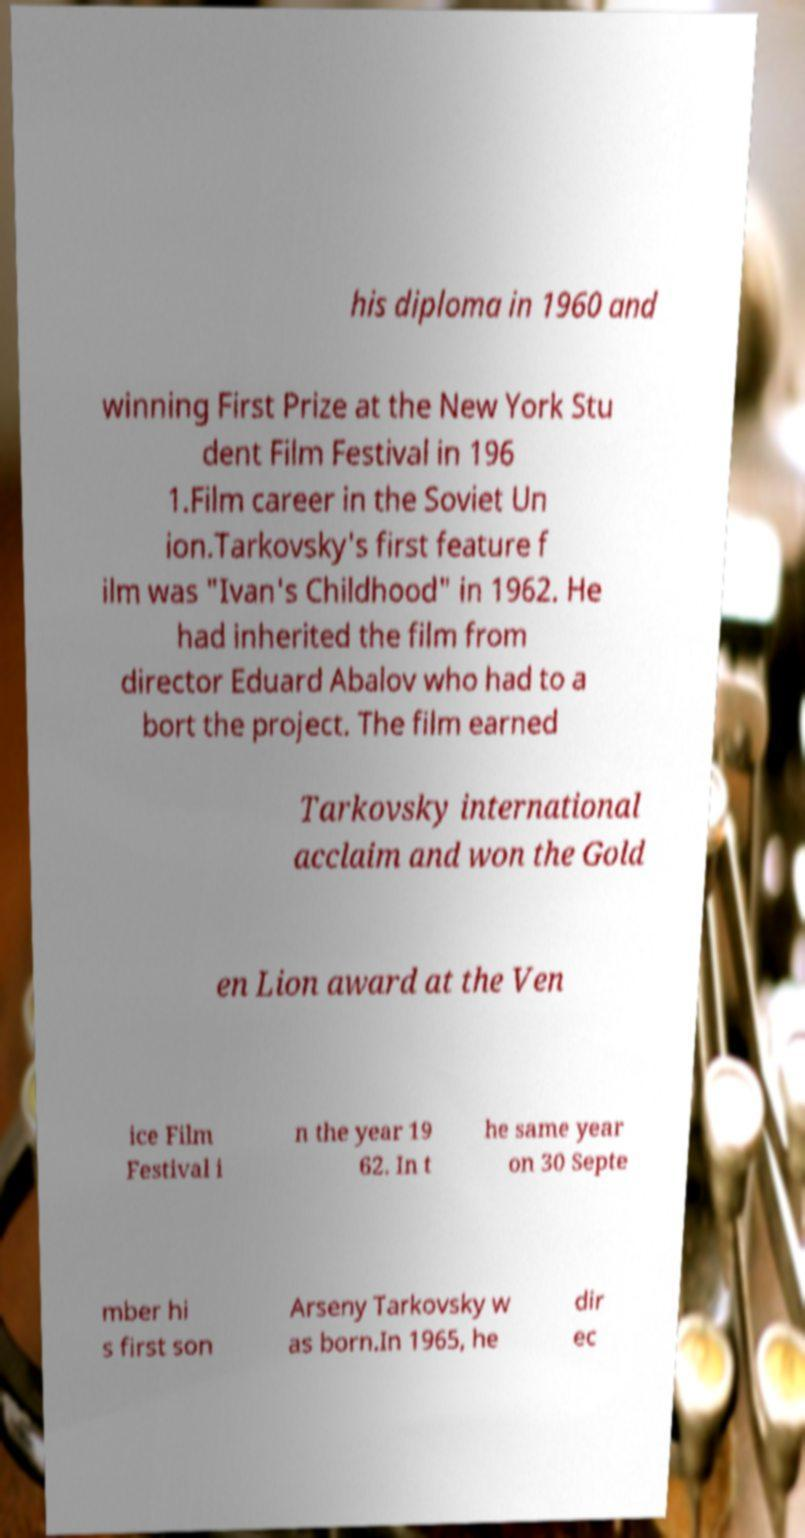There's text embedded in this image that I need extracted. Can you transcribe it verbatim? his diploma in 1960 and winning First Prize at the New York Stu dent Film Festival in 196 1.Film career in the Soviet Un ion.Tarkovsky's first feature f ilm was "Ivan's Childhood" in 1962. He had inherited the film from director Eduard Abalov who had to a bort the project. The film earned Tarkovsky international acclaim and won the Gold en Lion award at the Ven ice Film Festival i n the year 19 62. In t he same year on 30 Septe mber hi s first son Arseny Tarkovsky w as born.In 1965, he dir ec 